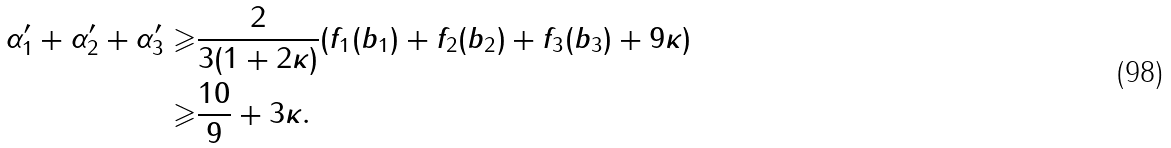<formula> <loc_0><loc_0><loc_500><loc_500>\alpha _ { 1 } ^ { \prime } + \alpha _ { 2 } ^ { \prime } + \alpha _ { 3 } ^ { \prime } \geqslant & \frac { 2 } { 3 ( 1 + 2 \kappa ) } ( f _ { 1 } ( b _ { 1 } ) + f _ { 2 } ( b _ { 2 } ) + f _ { 3 } ( b _ { 3 } ) + 9 \kappa ) \\ \geqslant & \frac { 1 0 } { 9 } + 3 \kappa .</formula> 